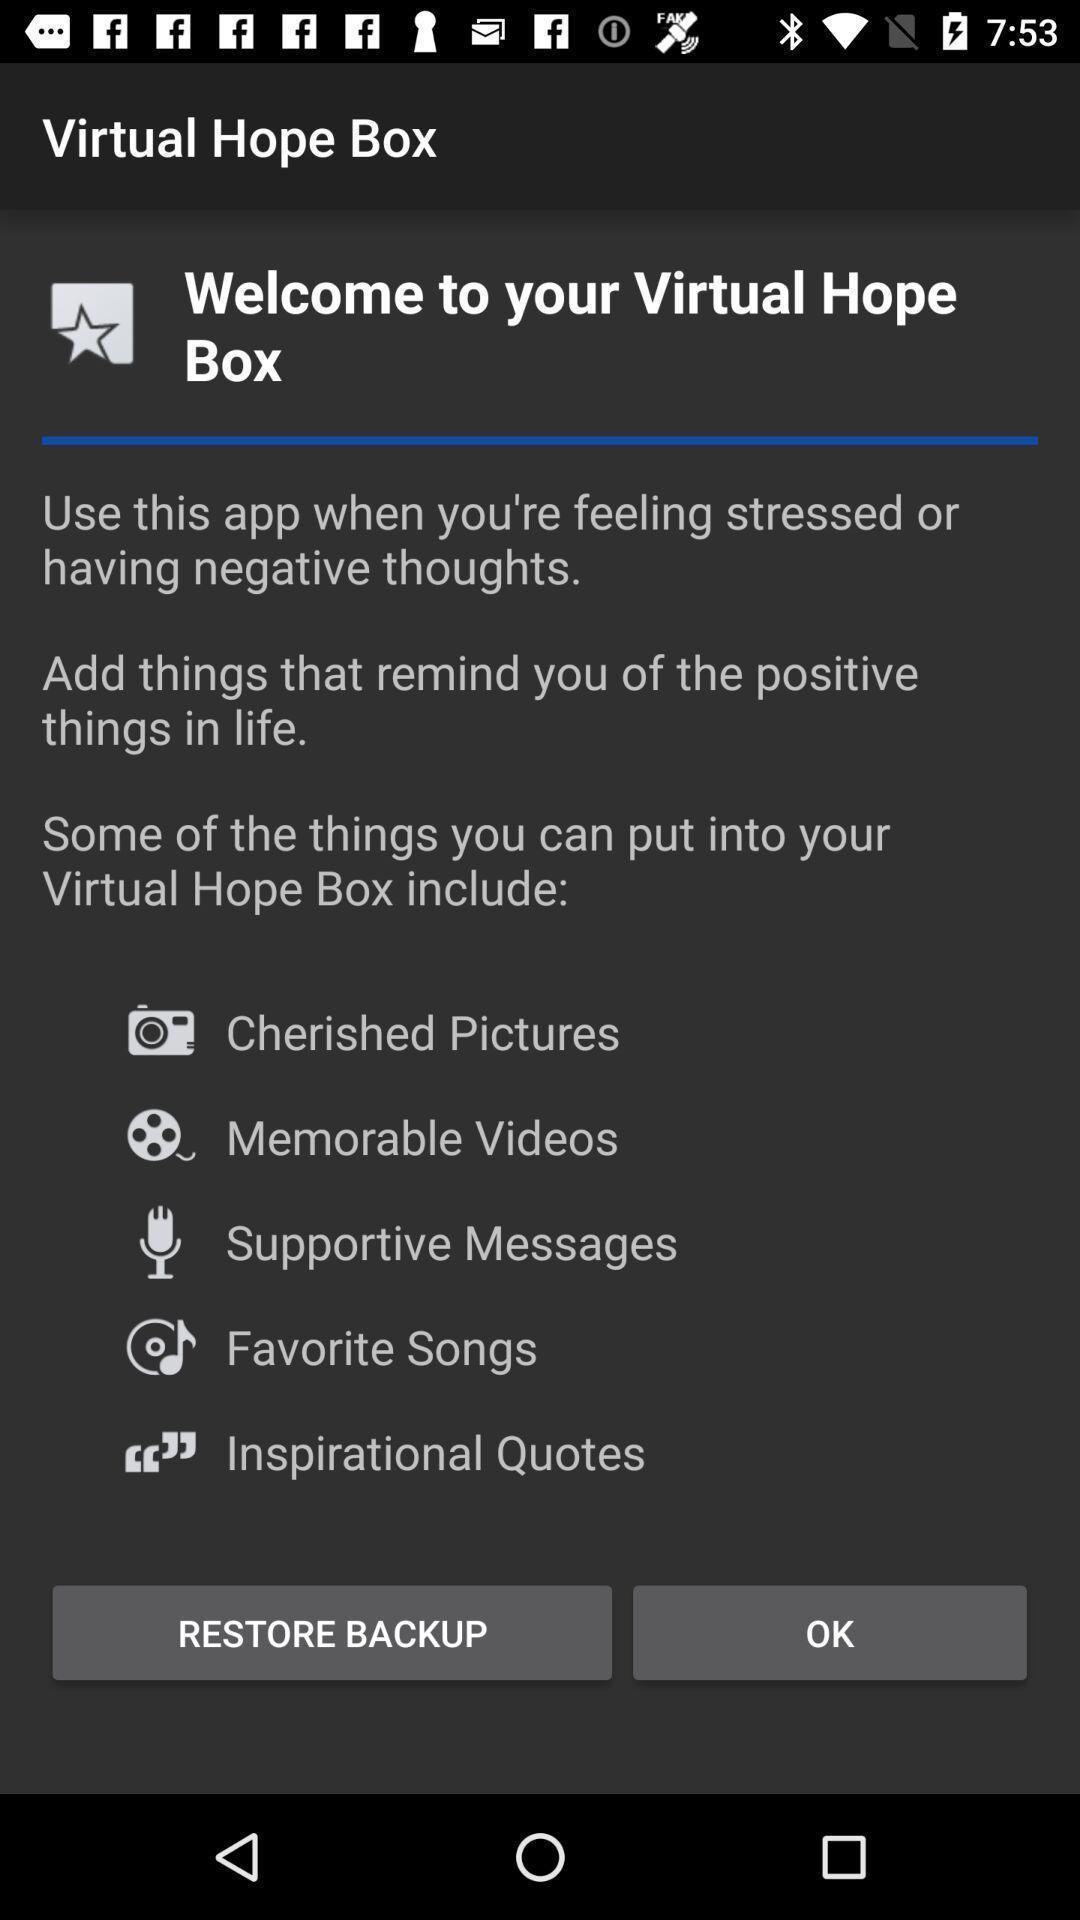Provide a detailed account of this screenshot. Welcome page. 